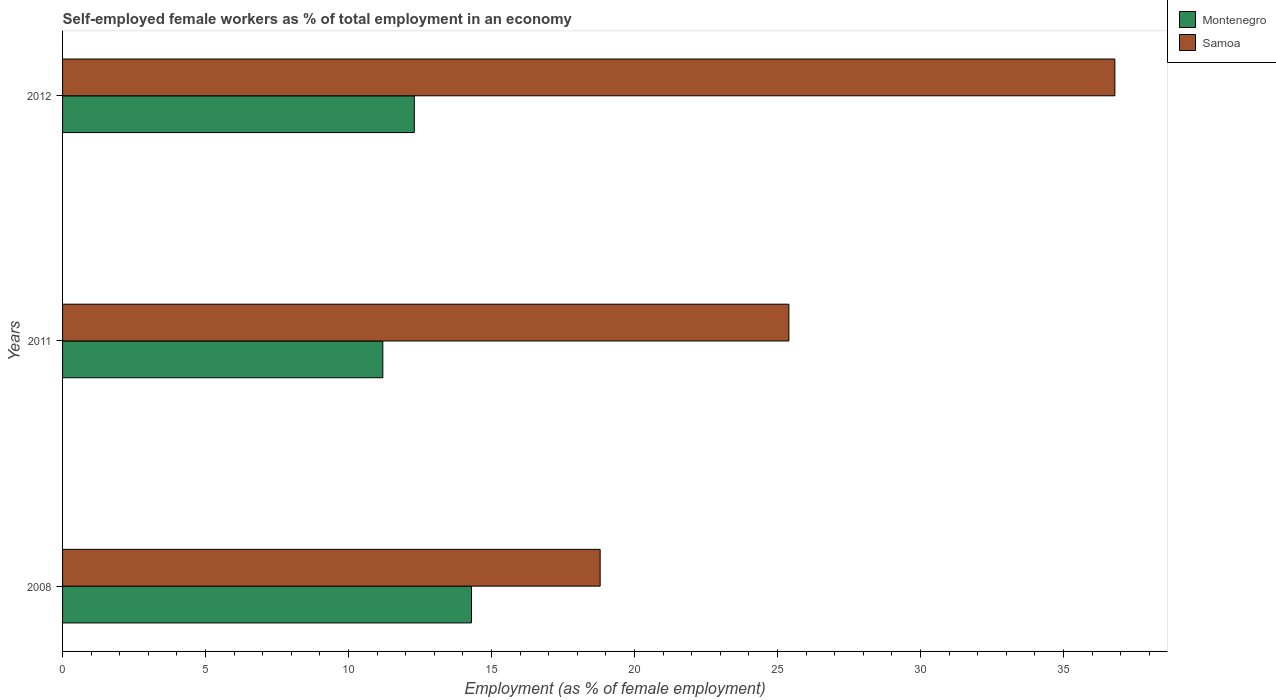How many bars are there on the 2nd tick from the top?
Offer a very short reply. 2. In how many cases, is the number of bars for a given year not equal to the number of legend labels?
Make the answer very short. 0. What is the percentage of self-employed female workers in Samoa in 2011?
Your response must be concise. 25.4. Across all years, what is the maximum percentage of self-employed female workers in Samoa?
Make the answer very short. 36.8. Across all years, what is the minimum percentage of self-employed female workers in Montenegro?
Provide a succinct answer. 11.2. In which year was the percentage of self-employed female workers in Montenegro maximum?
Your answer should be compact. 2008. In which year was the percentage of self-employed female workers in Montenegro minimum?
Provide a succinct answer. 2011. What is the total percentage of self-employed female workers in Montenegro in the graph?
Provide a short and direct response. 37.8. What is the difference between the percentage of self-employed female workers in Samoa in 2008 and the percentage of self-employed female workers in Montenegro in 2012?
Provide a short and direct response. 6.5. What is the average percentage of self-employed female workers in Montenegro per year?
Offer a terse response. 12.6. In the year 2008, what is the difference between the percentage of self-employed female workers in Samoa and percentage of self-employed female workers in Montenegro?
Provide a short and direct response. 4.5. What is the ratio of the percentage of self-employed female workers in Samoa in 2008 to that in 2012?
Provide a succinct answer. 0.51. Is the difference between the percentage of self-employed female workers in Samoa in 2008 and 2012 greater than the difference between the percentage of self-employed female workers in Montenegro in 2008 and 2012?
Keep it short and to the point. No. What is the difference between the highest and the lowest percentage of self-employed female workers in Samoa?
Provide a succinct answer. 18. In how many years, is the percentage of self-employed female workers in Montenegro greater than the average percentage of self-employed female workers in Montenegro taken over all years?
Your answer should be compact. 1. Is the sum of the percentage of self-employed female workers in Montenegro in 2008 and 2012 greater than the maximum percentage of self-employed female workers in Samoa across all years?
Give a very brief answer. No. What does the 1st bar from the top in 2008 represents?
Your answer should be very brief. Samoa. What does the 2nd bar from the bottom in 2012 represents?
Keep it short and to the point. Samoa. Are all the bars in the graph horizontal?
Your answer should be compact. Yes. What is the difference between two consecutive major ticks on the X-axis?
Provide a succinct answer. 5. Does the graph contain grids?
Offer a very short reply. No. How are the legend labels stacked?
Your answer should be very brief. Vertical. What is the title of the graph?
Your response must be concise. Self-employed female workers as % of total employment in an economy. Does "Brazil" appear as one of the legend labels in the graph?
Provide a succinct answer. No. What is the label or title of the X-axis?
Keep it short and to the point. Employment (as % of female employment). What is the Employment (as % of female employment) of Montenegro in 2008?
Offer a terse response. 14.3. What is the Employment (as % of female employment) in Samoa in 2008?
Offer a very short reply. 18.8. What is the Employment (as % of female employment) in Montenegro in 2011?
Offer a very short reply. 11.2. What is the Employment (as % of female employment) of Samoa in 2011?
Provide a succinct answer. 25.4. What is the Employment (as % of female employment) in Montenegro in 2012?
Provide a succinct answer. 12.3. What is the Employment (as % of female employment) in Samoa in 2012?
Provide a succinct answer. 36.8. Across all years, what is the maximum Employment (as % of female employment) in Montenegro?
Keep it short and to the point. 14.3. Across all years, what is the maximum Employment (as % of female employment) of Samoa?
Keep it short and to the point. 36.8. Across all years, what is the minimum Employment (as % of female employment) of Montenegro?
Your answer should be compact. 11.2. Across all years, what is the minimum Employment (as % of female employment) in Samoa?
Give a very brief answer. 18.8. What is the total Employment (as % of female employment) of Montenegro in the graph?
Your answer should be compact. 37.8. What is the difference between the Employment (as % of female employment) of Samoa in 2008 and that in 2011?
Offer a very short reply. -6.6. What is the difference between the Employment (as % of female employment) of Montenegro in 2008 and that in 2012?
Offer a very short reply. 2. What is the difference between the Employment (as % of female employment) in Samoa in 2008 and that in 2012?
Your answer should be compact. -18. What is the difference between the Employment (as % of female employment) in Samoa in 2011 and that in 2012?
Keep it short and to the point. -11.4. What is the difference between the Employment (as % of female employment) of Montenegro in 2008 and the Employment (as % of female employment) of Samoa in 2012?
Your answer should be compact. -22.5. What is the difference between the Employment (as % of female employment) of Montenegro in 2011 and the Employment (as % of female employment) of Samoa in 2012?
Provide a succinct answer. -25.6. What is the average Employment (as % of female employment) in Samoa per year?
Offer a terse response. 27. In the year 2011, what is the difference between the Employment (as % of female employment) of Montenegro and Employment (as % of female employment) of Samoa?
Your answer should be compact. -14.2. In the year 2012, what is the difference between the Employment (as % of female employment) in Montenegro and Employment (as % of female employment) in Samoa?
Offer a very short reply. -24.5. What is the ratio of the Employment (as % of female employment) in Montenegro in 2008 to that in 2011?
Your answer should be compact. 1.28. What is the ratio of the Employment (as % of female employment) in Samoa in 2008 to that in 2011?
Your response must be concise. 0.74. What is the ratio of the Employment (as % of female employment) of Montenegro in 2008 to that in 2012?
Ensure brevity in your answer.  1.16. What is the ratio of the Employment (as % of female employment) in Samoa in 2008 to that in 2012?
Make the answer very short. 0.51. What is the ratio of the Employment (as % of female employment) in Montenegro in 2011 to that in 2012?
Make the answer very short. 0.91. What is the ratio of the Employment (as % of female employment) in Samoa in 2011 to that in 2012?
Provide a short and direct response. 0.69. What is the difference between the highest and the second highest Employment (as % of female employment) of Montenegro?
Make the answer very short. 2. What is the difference between the highest and the lowest Employment (as % of female employment) in Montenegro?
Offer a very short reply. 3.1. What is the difference between the highest and the lowest Employment (as % of female employment) in Samoa?
Make the answer very short. 18. 